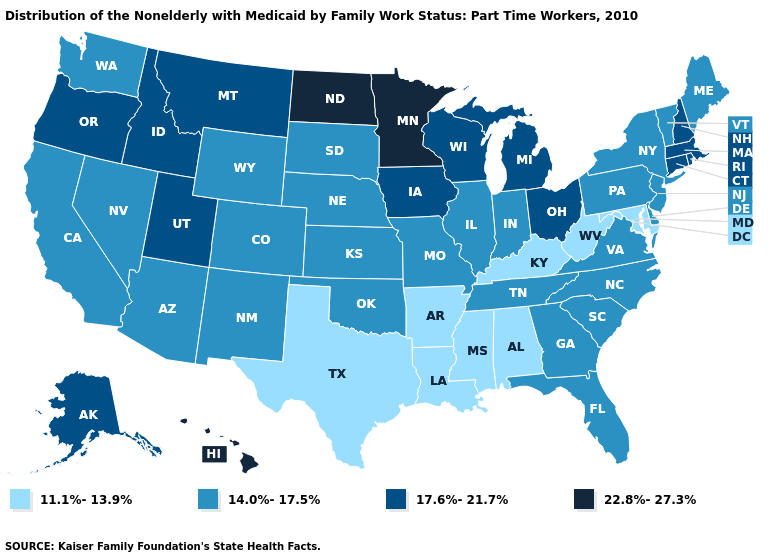Does Colorado have the highest value in the West?
Concise answer only. No. Among the states that border Michigan , which have the lowest value?
Keep it brief. Indiana. Name the states that have a value in the range 17.6%-21.7%?
Give a very brief answer. Alaska, Connecticut, Idaho, Iowa, Massachusetts, Michigan, Montana, New Hampshire, Ohio, Oregon, Rhode Island, Utah, Wisconsin. Does Kentucky have the lowest value in the South?
Keep it brief. Yes. Name the states that have a value in the range 22.8%-27.3%?
Quick response, please. Hawaii, Minnesota, North Dakota. Does California have a lower value than Ohio?
Short answer required. Yes. Among the states that border Pennsylvania , does New York have the lowest value?
Short answer required. No. Among the states that border Minnesota , which have the highest value?
Give a very brief answer. North Dakota. Does Minnesota have the highest value in the USA?
Keep it brief. Yes. Does New Mexico have the lowest value in the USA?
Quick response, please. No. What is the value of New Jersey?
Short answer required. 14.0%-17.5%. What is the highest value in states that border Indiana?
Be succinct. 17.6%-21.7%. Does Minnesota have the highest value in the USA?
Keep it brief. Yes. How many symbols are there in the legend?
Keep it brief. 4. 